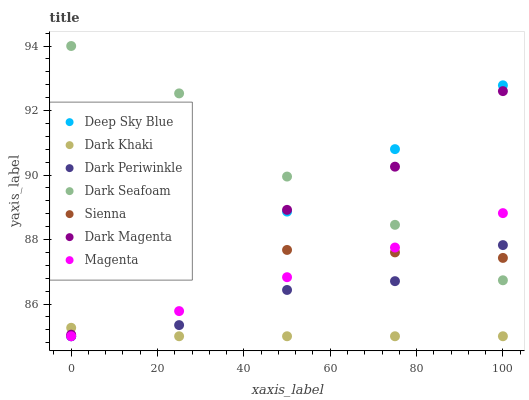Does Dark Khaki have the minimum area under the curve?
Answer yes or no. Yes. Does Dark Seafoam have the maximum area under the curve?
Answer yes or no. Yes. Does Dark Magenta have the minimum area under the curve?
Answer yes or no. No. Does Dark Magenta have the maximum area under the curve?
Answer yes or no. No. Is Dark Khaki the smoothest?
Answer yes or no. Yes. Is Dark Seafoam the roughest?
Answer yes or no. Yes. Is Dark Magenta the smoothest?
Answer yes or no. No. Is Dark Magenta the roughest?
Answer yes or no. No. Does Dark Khaki have the lowest value?
Answer yes or no. Yes. Does Dark Magenta have the lowest value?
Answer yes or no. No. Does Dark Seafoam have the highest value?
Answer yes or no. Yes. Does Dark Magenta have the highest value?
Answer yes or no. No. Is Dark Khaki less than Sienna?
Answer yes or no. Yes. Is Dark Seafoam greater than Dark Khaki?
Answer yes or no. Yes. Does Dark Magenta intersect Sienna?
Answer yes or no. Yes. Is Dark Magenta less than Sienna?
Answer yes or no. No. Is Dark Magenta greater than Sienna?
Answer yes or no. No. Does Dark Khaki intersect Sienna?
Answer yes or no. No. 